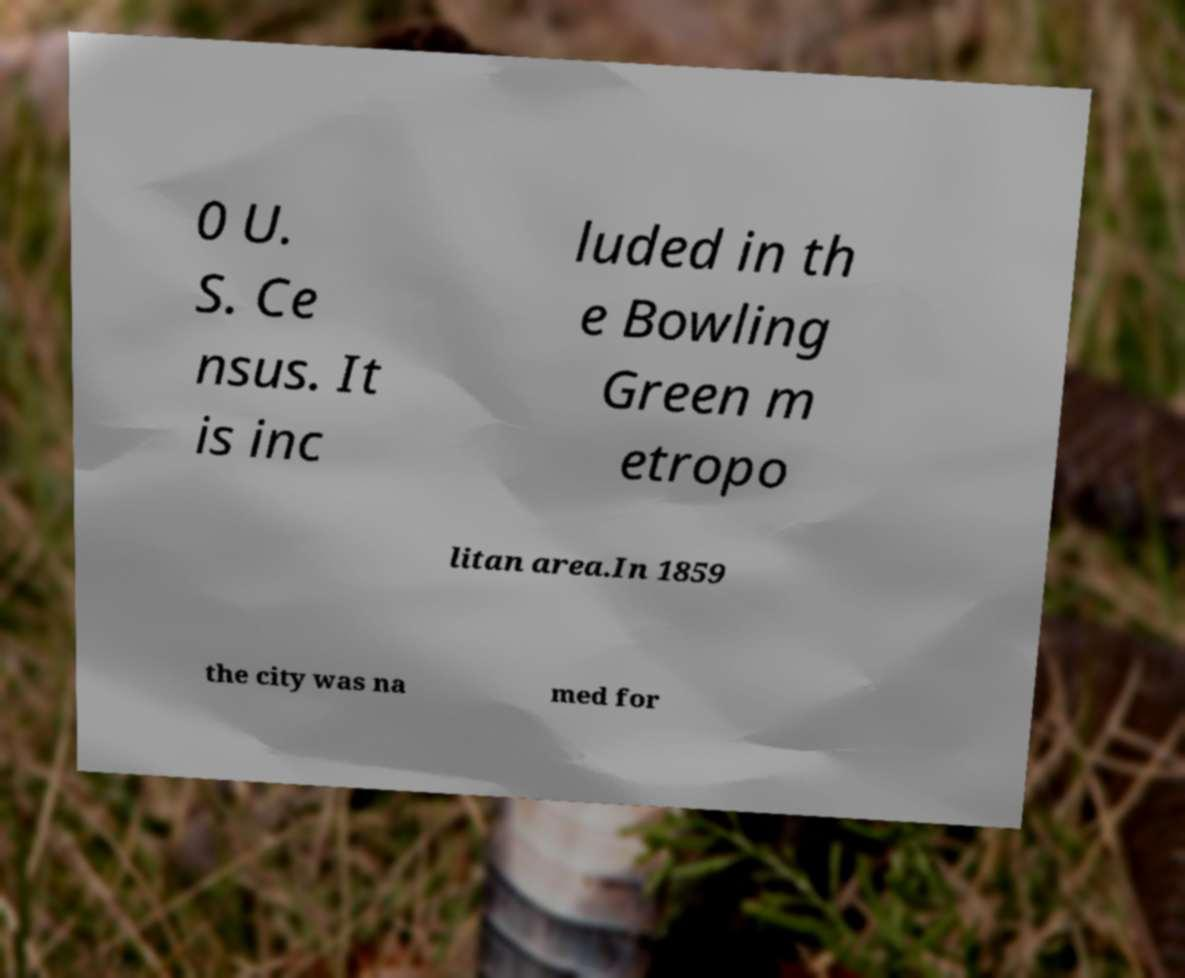Could you extract and type out the text from this image? 0 U. S. Ce nsus. It is inc luded in th e Bowling Green m etropo litan area.In 1859 the city was na med for 